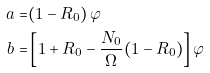Convert formula to latex. <formula><loc_0><loc_0><loc_500><loc_500>a = & ( 1 - R _ { 0 } ) \, \varphi \\ b = & \left [ 1 + R _ { 0 } - \frac { N _ { 0 } } { \Omega } ( 1 - R _ { 0 } ) \right ] \varphi</formula> 